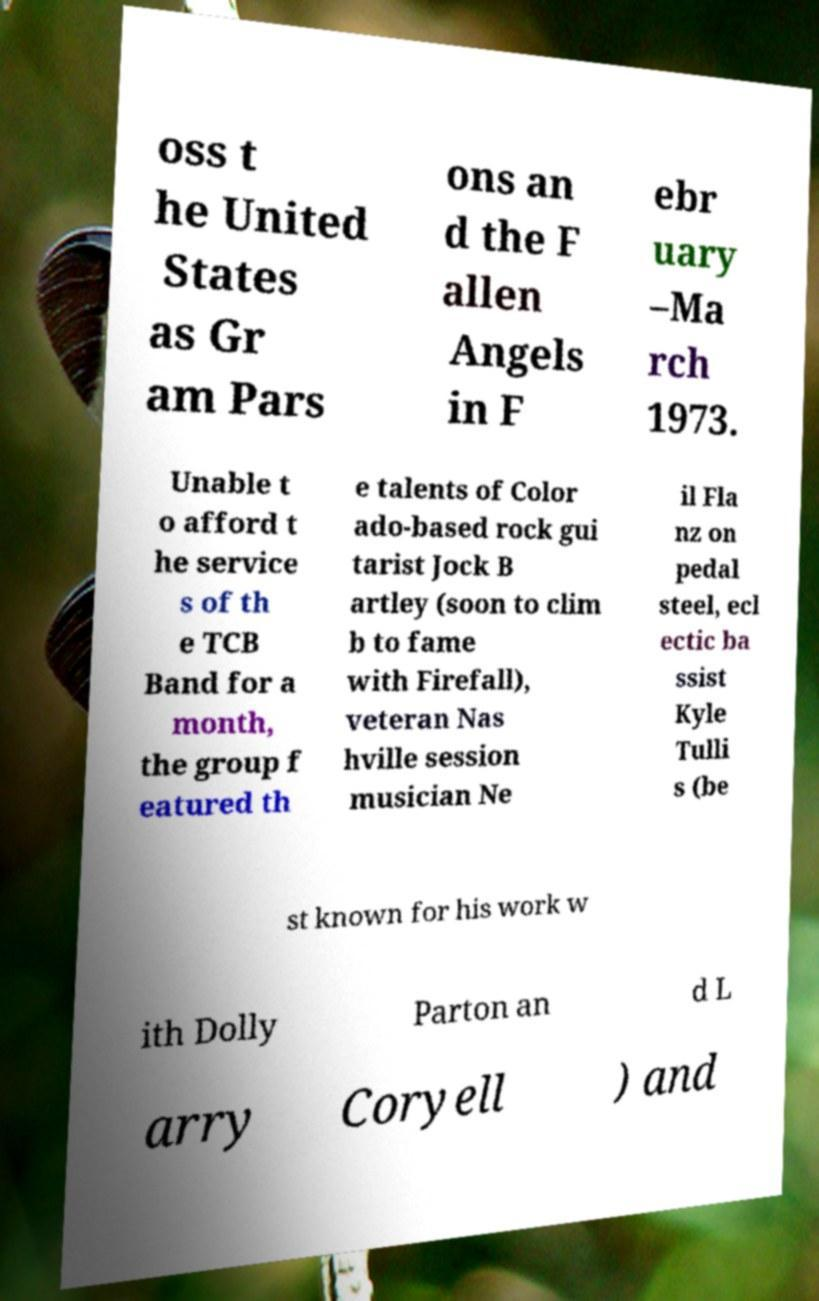For documentation purposes, I need the text within this image transcribed. Could you provide that? oss t he United States as Gr am Pars ons an d the F allen Angels in F ebr uary –Ma rch 1973. Unable t o afford t he service s of th e TCB Band for a month, the group f eatured th e talents of Color ado-based rock gui tarist Jock B artley (soon to clim b to fame with Firefall), veteran Nas hville session musician Ne il Fla nz on pedal steel, ecl ectic ba ssist Kyle Tulli s (be st known for his work w ith Dolly Parton an d L arry Coryell ) and 